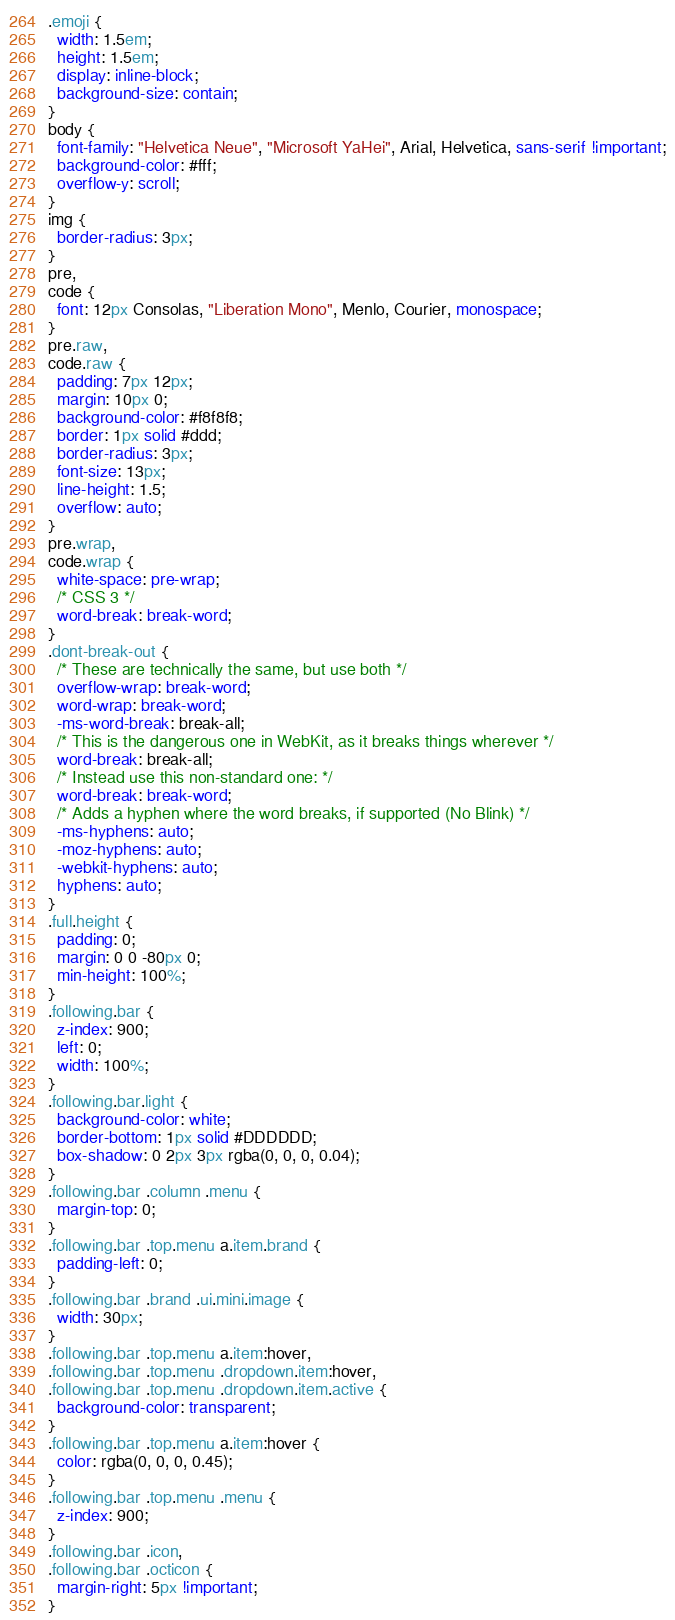<code> <loc_0><loc_0><loc_500><loc_500><_CSS_>.emoji {
  width: 1.5em;
  height: 1.5em;
  display: inline-block;
  background-size: contain;
}
body {
  font-family: "Helvetica Neue", "Microsoft YaHei", Arial, Helvetica, sans-serif !important;
  background-color: #fff;
  overflow-y: scroll;
}
img {
  border-radius: 3px;
}
pre,
code {
  font: 12px Consolas, "Liberation Mono", Menlo, Courier, monospace;
}
pre.raw,
code.raw {
  padding: 7px 12px;
  margin: 10px 0;
  background-color: #f8f8f8;
  border: 1px solid #ddd;
  border-radius: 3px;
  font-size: 13px;
  line-height: 1.5;
  overflow: auto;
}
pre.wrap,
code.wrap {
  white-space: pre-wrap;
  /* CSS 3 */
  word-break: break-word;
}
.dont-break-out {
  /* These are technically the same, but use both */
  overflow-wrap: break-word;
  word-wrap: break-word;
  -ms-word-break: break-all;
  /* This is the dangerous one in WebKit, as it breaks things wherever */
  word-break: break-all;
  /* Instead use this non-standard one: */
  word-break: break-word;
  /* Adds a hyphen where the word breaks, if supported (No Blink) */
  -ms-hyphens: auto;
  -moz-hyphens: auto;
  -webkit-hyphens: auto;
  hyphens: auto;
}
.full.height {
  padding: 0;
  margin: 0 0 -80px 0;
  min-height: 100%;
}
.following.bar {
  z-index: 900;
  left: 0;
  width: 100%;
}
.following.bar.light {
  background-color: white;
  border-bottom: 1px solid #DDDDDD;
  box-shadow: 0 2px 3px rgba(0, 0, 0, 0.04);
}
.following.bar .column .menu {
  margin-top: 0;
}
.following.bar .top.menu a.item.brand {
  padding-left: 0;
}
.following.bar .brand .ui.mini.image {
  width: 30px;
}
.following.bar .top.menu a.item:hover,
.following.bar .top.menu .dropdown.item:hover,
.following.bar .top.menu .dropdown.item.active {
  background-color: transparent;
}
.following.bar .top.menu a.item:hover {
  color: rgba(0, 0, 0, 0.45);
}
.following.bar .top.menu .menu {
  z-index: 900;
}
.following.bar .icon,
.following.bar .octicon {
  margin-right: 5px !important;
}</code> 